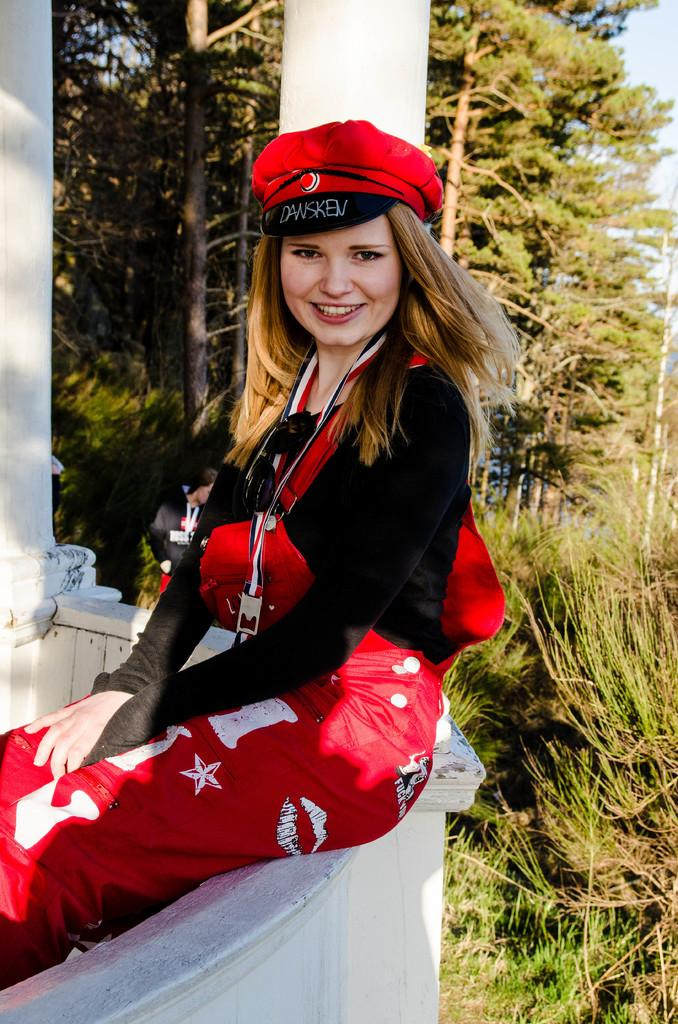Who is the main subject in the image? There is a girl in the image. What is the girl doing in the image? The girl is sitting on a wall. What is the girl wearing in the image? The girl is wearing a black t-shirt, red trousers, and a cap. What can be seen in the background of the image? There are trees visible in the background of the image. How many letters are visible on the girl's cap in the image? There are no letters visible on the girl's cap in the image. What type of mint is growing near the girl in the image? There is no mint present in the image. 